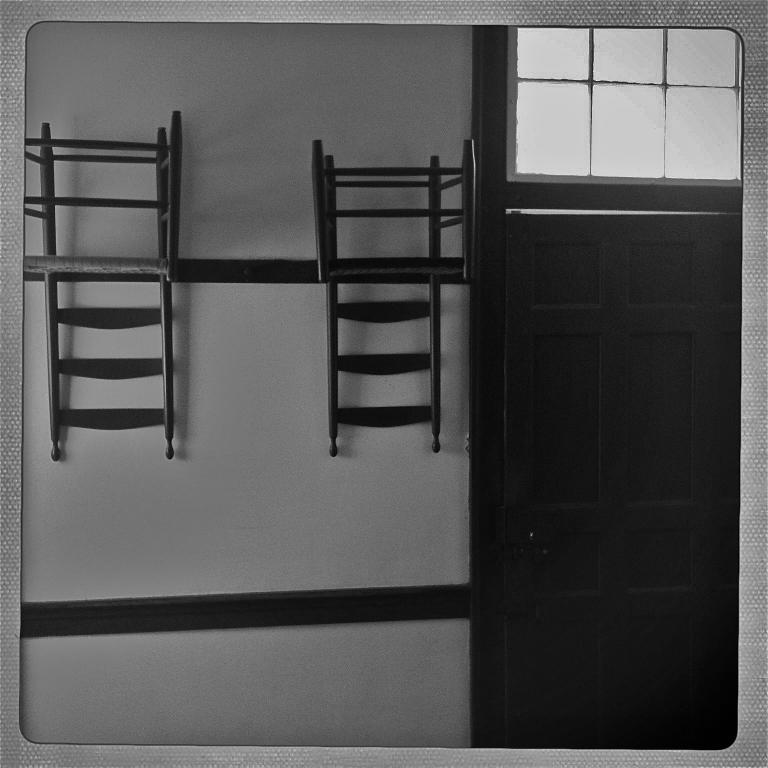What is present on the wall in the image? Chairs are hanging on the wall in the image. What is located beside the wall? There is a door beside the wall. What is the color of the door? The door is black in color. What is the color of the wall? The wall is white in color. Can you see any jellyfish swimming on the wall in the image? There are no jellyfish present in the image; it features chairs hanging on a white wall and a black door beside it. 